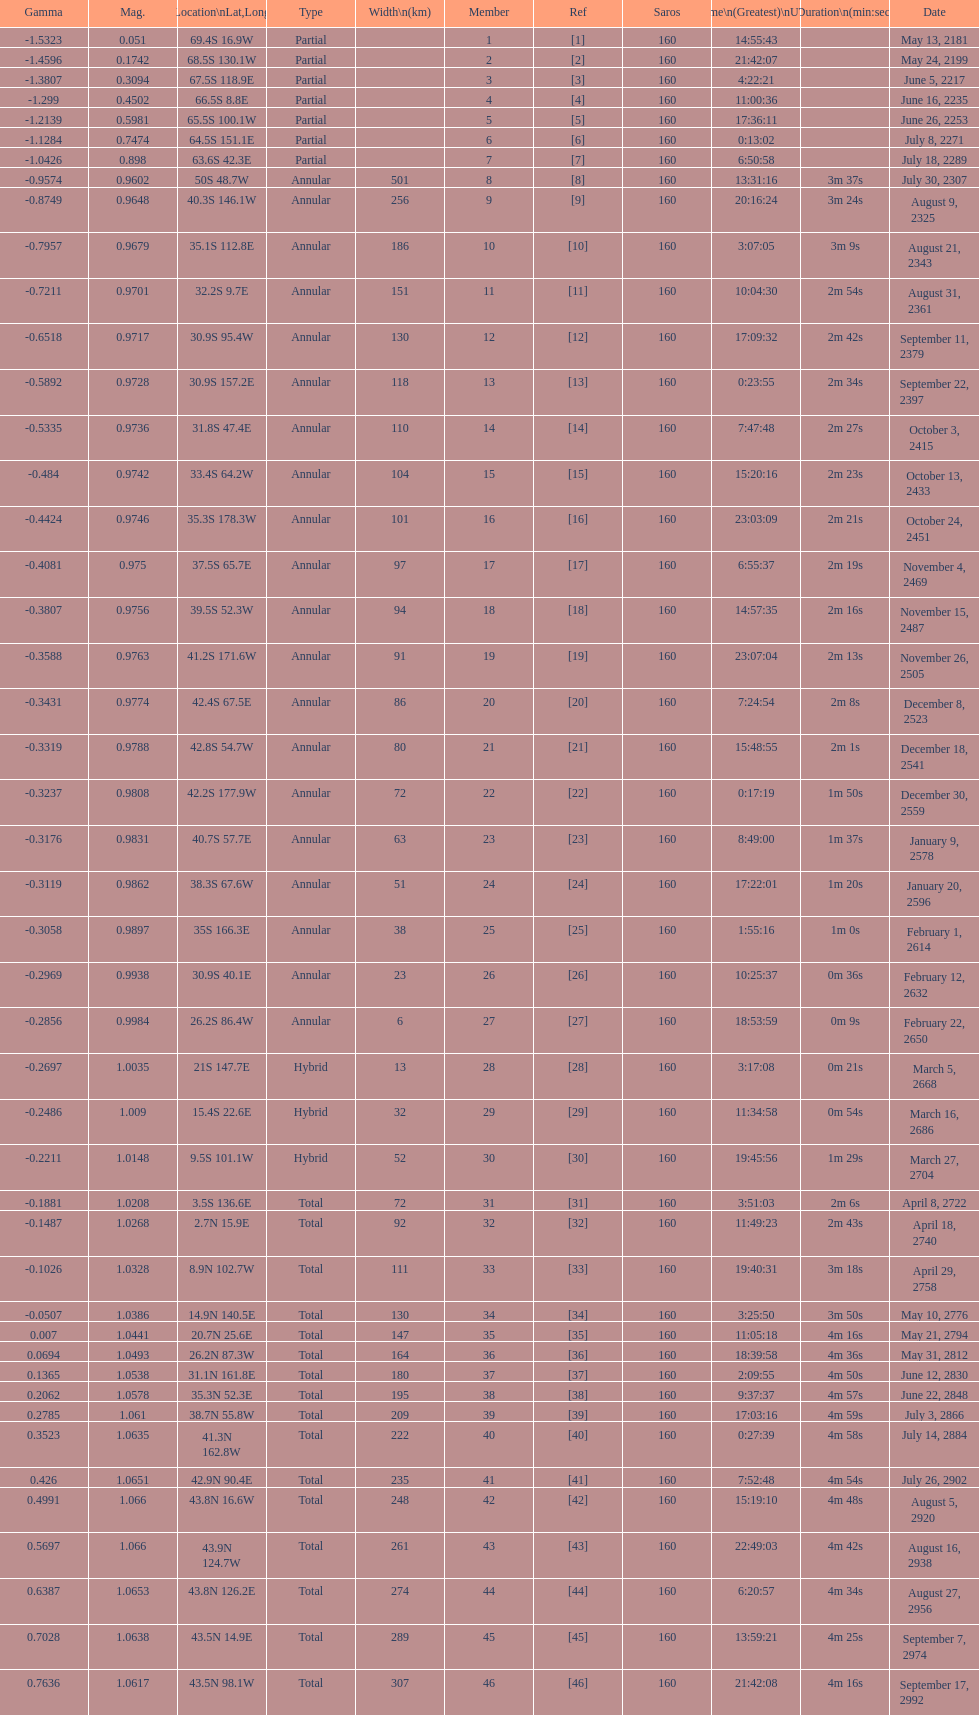Name one that has the same latitude as member number 12. 13. I'm looking to parse the entire table for insights. Could you assist me with that? {'header': ['Gamma', 'Mag.', 'Location\\nLat,Long', 'Type', 'Width\\n(km)', 'Member', 'Ref', 'Saros', 'Time\\n(Greatest)\\nUTC', 'Duration\\n(min:sec)', 'Date'], 'rows': [['-1.5323', '0.051', '69.4S 16.9W', 'Partial', '', '1', '[1]', '160', '14:55:43', '', 'May 13, 2181'], ['-1.4596', '0.1742', '68.5S 130.1W', 'Partial', '', '2', '[2]', '160', '21:42:07', '', 'May 24, 2199'], ['-1.3807', '0.3094', '67.5S 118.9E', 'Partial', '', '3', '[3]', '160', '4:22:21', '', 'June 5, 2217'], ['-1.299', '0.4502', '66.5S 8.8E', 'Partial', '', '4', '[4]', '160', '11:00:36', '', 'June 16, 2235'], ['-1.2139', '0.5981', '65.5S 100.1W', 'Partial', '', '5', '[5]', '160', '17:36:11', '', 'June 26, 2253'], ['-1.1284', '0.7474', '64.5S 151.1E', 'Partial', '', '6', '[6]', '160', '0:13:02', '', 'July 8, 2271'], ['-1.0426', '0.898', '63.6S 42.3E', 'Partial', '', '7', '[7]', '160', '6:50:58', '', 'July 18, 2289'], ['-0.9574', '0.9602', '50S 48.7W', 'Annular', '501', '8', '[8]', '160', '13:31:16', '3m 37s', 'July 30, 2307'], ['-0.8749', '0.9648', '40.3S 146.1W', 'Annular', '256', '9', '[9]', '160', '20:16:24', '3m 24s', 'August 9, 2325'], ['-0.7957', '0.9679', '35.1S 112.8E', 'Annular', '186', '10', '[10]', '160', '3:07:05', '3m 9s', 'August 21, 2343'], ['-0.7211', '0.9701', '32.2S 9.7E', 'Annular', '151', '11', '[11]', '160', '10:04:30', '2m 54s', 'August 31, 2361'], ['-0.6518', '0.9717', '30.9S 95.4W', 'Annular', '130', '12', '[12]', '160', '17:09:32', '2m 42s', 'September 11, 2379'], ['-0.5892', '0.9728', '30.9S 157.2E', 'Annular', '118', '13', '[13]', '160', '0:23:55', '2m 34s', 'September 22, 2397'], ['-0.5335', '0.9736', '31.8S 47.4E', 'Annular', '110', '14', '[14]', '160', '7:47:48', '2m 27s', 'October 3, 2415'], ['-0.484', '0.9742', '33.4S 64.2W', 'Annular', '104', '15', '[15]', '160', '15:20:16', '2m 23s', 'October 13, 2433'], ['-0.4424', '0.9746', '35.3S 178.3W', 'Annular', '101', '16', '[16]', '160', '23:03:09', '2m 21s', 'October 24, 2451'], ['-0.4081', '0.975', '37.5S 65.7E', 'Annular', '97', '17', '[17]', '160', '6:55:37', '2m 19s', 'November 4, 2469'], ['-0.3807', '0.9756', '39.5S 52.3W', 'Annular', '94', '18', '[18]', '160', '14:57:35', '2m 16s', 'November 15, 2487'], ['-0.3588', '0.9763', '41.2S 171.6W', 'Annular', '91', '19', '[19]', '160', '23:07:04', '2m 13s', 'November 26, 2505'], ['-0.3431', '0.9774', '42.4S 67.5E', 'Annular', '86', '20', '[20]', '160', '7:24:54', '2m 8s', 'December 8, 2523'], ['-0.3319', '0.9788', '42.8S 54.7W', 'Annular', '80', '21', '[21]', '160', '15:48:55', '2m 1s', 'December 18, 2541'], ['-0.3237', '0.9808', '42.2S 177.9W', 'Annular', '72', '22', '[22]', '160', '0:17:19', '1m 50s', 'December 30, 2559'], ['-0.3176', '0.9831', '40.7S 57.7E', 'Annular', '63', '23', '[23]', '160', '8:49:00', '1m 37s', 'January 9, 2578'], ['-0.3119', '0.9862', '38.3S 67.6W', 'Annular', '51', '24', '[24]', '160', '17:22:01', '1m 20s', 'January 20, 2596'], ['-0.3058', '0.9897', '35S 166.3E', 'Annular', '38', '25', '[25]', '160', '1:55:16', '1m 0s', 'February 1, 2614'], ['-0.2969', '0.9938', '30.9S 40.1E', 'Annular', '23', '26', '[26]', '160', '10:25:37', '0m 36s', 'February 12, 2632'], ['-0.2856', '0.9984', '26.2S 86.4W', 'Annular', '6', '27', '[27]', '160', '18:53:59', '0m 9s', 'February 22, 2650'], ['-0.2697', '1.0035', '21S 147.7E', 'Hybrid', '13', '28', '[28]', '160', '3:17:08', '0m 21s', 'March 5, 2668'], ['-0.2486', '1.009', '15.4S 22.6E', 'Hybrid', '32', '29', '[29]', '160', '11:34:58', '0m 54s', 'March 16, 2686'], ['-0.2211', '1.0148', '9.5S 101.1W', 'Hybrid', '52', '30', '[30]', '160', '19:45:56', '1m 29s', 'March 27, 2704'], ['-0.1881', '1.0208', '3.5S 136.6E', 'Total', '72', '31', '[31]', '160', '3:51:03', '2m 6s', 'April 8, 2722'], ['-0.1487', '1.0268', '2.7N 15.9E', 'Total', '92', '32', '[32]', '160', '11:49:23', '2m 43s', 'April 18, 2740'], ['-0.1026', '1.0328', '8.9N 102.7W', 'Total', '111', '33', '[33]', '160', '19:40:31', '3m 18s', 'April 29, 2758'], ['-0.0507', '1.0386', '14.9N 140.5E', 'Total', '130', '34', '[34]', '160', '3:25:50', '3m 50s', 'May 10, 2776'], ['0.007', '1.0441', '20.7N 25.6E', 'Total', '147', '35', '[35]', '160', '11:05:18', '4m 16s', 'May 21, 2794'], ['0.0694', '1.0493', '26.2N 87.3W', 'Total', '164', '36', '[36]', '160', '18:39:58', '4m 36s', 'May 31, 2812'], ['0.1365', '1.0538', '31.1N 161.8E', 'Total', '180', '37', '[37]', '160', '2:09:55', '4m 50s', 'June 12, 2830'], ['0.2062', '1.0578', '35.3N 52.3E', 'Total', '195', '38', '[38]', '160', '9:37:37', '4m 57s', 'June 22, 2848'], ['0.2785', '1.061', '38.7N 55.8W', 'Total', '209', '39', '[39]', '160', '17:03:16', '4m 59s', 'July 3, 2866'], ['0.3523', '1.0635', '41.3N 162.8W', 'Total', '222', '40', '[40]', '160', '0:27:39', '4m 58s', 'July 14, 2884'], ['0.426', '1.0651', '42.9N 90.4E', 'Total', '235', '41', '[41]', '160', '7:52:48', '4m 54s', 'July 26, 2902'], ['0.4991', '1.066', '43.8N 16.6W', 'Total', '248', '42', '[42]', '160', '15:19:10', '4m 48s', 'August 5, 2920'], ['0.5697', '1.066', '43.9N 124.7W', 'Total', '261', '43', '[43]', '160', '22:49:03', '4m 42s', 'August 16, 2938'], ['0.6387', '1.0653', '43.8N 126.2E', 'Total', '274', '44', '[44]', '160', '6:20:57', '4m 34s', 'August 27, 2956'], ['0.7028', '1.0638', '43.5N 14.9E', 'Total', '289', '45', '[45]', '160', '13:59:21', '4m 25s', 'September 7, 2974'], ['0.7636', '1.0617', '43.5N 98.1W', 'Total', '307', '46', '[46]', '160', '21:42:08', '4m 16s', 'September 17, 2992']]} 